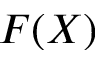Convert formula to latex. <formula><loc_0><loc_0><loc_500><loc_500>F ( X )</formula> 